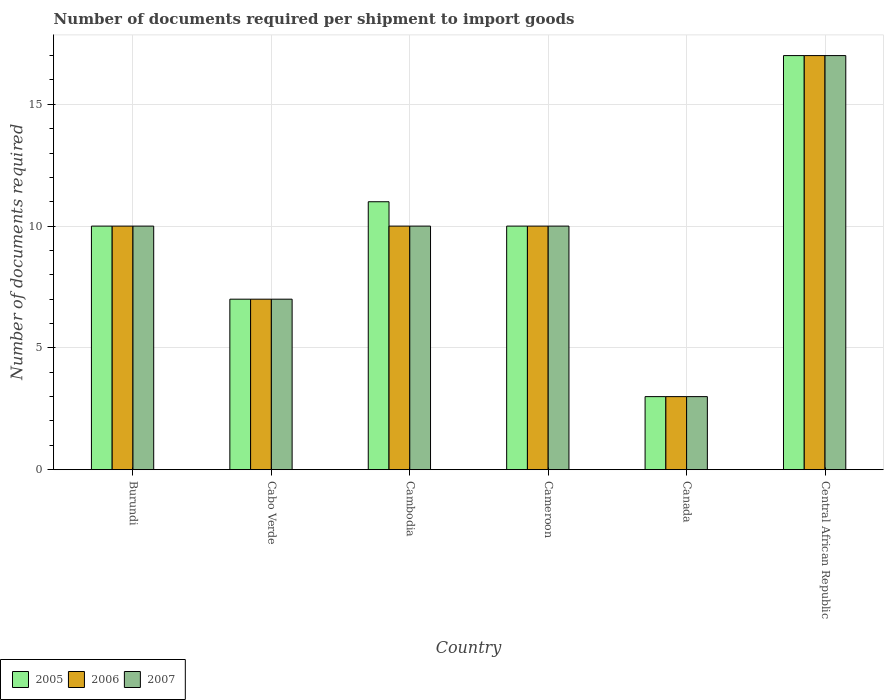Are the number of bars per tick equal to the number of legend labels?
Your answer should be compact. Yes. Are the number of bars on each tick of the X-axis equal?
Provide a succinct answer. Yes. What is the label of the 1st group of bars from the left?
Make the answer very short. Burundi. Across all countries, what is the maximum number of documents required per shipment to import goods in 2005?
Your answer should be very brief. 17. Across all countries, what is the minimum number of documents required per shipment to import goods in 2005?
Your answer should be compact. 3. In which country was the number of documents required per shipment to import goods in 2005 maximum?
Provide a succinct answer. Central African Republic. In which country was the number of documents required per shipment to import goods in 2005 minimum?
Give a very brief answer. Canada. What is the difference between the number of documents required per shipment to import goods in 2006 in Cambodia and the number of documents required per shipment to import goods in 2007 in Burundi?
Provide a succinct answer. 0. What is the average number of documents required per shipment to import goods in 2007 per country?
Give a very brief answer. 9.5. What is the ratio of the number of documents required per shipment to import goods in 2005 in Cabo Verde to that in Canada?
Offer a terse response. 2.33. Is the number of documents required per shipment to import goods in 2005 in Cambodia less than that in Cameroon?
Provide a succinct answer. No. What is the difference between the highest and the second highest number of documents required per shipment to import goods in 2007?
Ensure brevity in your answer.  7. What is the difference between the highest and the lowest number of documents required per shipment to import goods in 2007?
Your answer should be compact. 14. Is the sum of the number of documents required per shipment to import goods in 2007 in Canada and Central African Republic greater than the maximum number of documents required per shipment to import goods in 2006 across all countries?
Make the answer very short. Yes. What does the 1st bar from the left in Cabo Verde represents?
Your answer should be compact. 2005. Is it the case that in every country, the sum of the number of documents required per shipment to import goods in 2005 and number of documents required per shipment to import goods in 2007 is greater than the number of documents required per shipment to import goods in 2006?
Your answer should be compact. Yes. Are all the bars in the graph horizontal?
Make the answer very short. No. How many legend labels are there?
Your answer should be compact. 3. How are the legend labels stacked?
Your answer should be compact. Horizontal. What is the title of the graph?
Provide a short and direct response. Number of documents required per shipment to import goods. Does "1973" appear as one of the legend labels in the graph?
Offer a terse response. No. What is the label or title of the Y-axis?
Your response must be concise. Number of documents required. What is the Number of documents required of 2005 in Burundi?
Ensure brevity in your answer.  10. What is the Number of documents required of 2006 in Cabo Verde?
Offer a terse response. 7. What is the Number of documents required in 2007 in Cabo Verde?
Offer a terse response. 7. What is the Number of documents required in 2005 in Cambodia?
Offer a terse response. 11. What is the Number of documents required in 2006 in Cambodia?
Give a very brief answer. 10. What is the Number of documents required in 2005 in Cameroon?
Your response must be concise. 10. What is the Number of documents required of 2006 in Cameroon?
Offer a terse response. 10. What is the Number of documents required of 2005 in Canada?
Ensure brevity in your answer.  3. What is the Number of documents required of 2007 in Canada?
Give a very brief answer. 3. What is the Number of documents required in 2005 in Central African Republic?
Make the answer very short. 17. What is the Number of documents required in 2006 in Central African Republic?
Your answer should be very brief. 17. Across all countries, what is the maximum Number of documents required in 2007?
Ensure brevity in your answer.  17. Across all countries, what is the minimum Number of documents required in 2006?
Make the answer very short. 3. Across all countries, what is the minimum Number of documents required of 2007?
Provide a succinct answer. 3. What is the total Number of documents required of 2005 in the graph?
Your response must be concise. 58. What is the total Number of documents required of 2007 in the graph?
Your answer should be very brief. 57. What is the difference between the Number of documents required of 2006 in Burundi and that in Cabo Verde?
Offer a very short reply. 3. What is the difference between the Number of documents required of 2005 in Burundi and that in Cambodia?
Keep it short and to the point. -1. What is the difference between the Number of documents required of 2007 in Burundi and that in Cambodia?
Your answer should be very brief. 0. What is the difference between the Number of documents required of 2005 in Burundi and that in Cameroon?
Give a very brief answer. 0. What is the difference between the Number of documents required in 2006 in Burundi and that in Cameroon?
Offer a very short reply. 0. What is the difference between the Number of documents required in 2005 in Burundi and that in Central African Republic?
Make the answer very short. -7. What is the difference between the Number of documents required of 2005 in Cabo Verde and that in Cambodia?
Your answer should be very brief. -4. What is the difference between the Number of documents required in 2006 in Cabo Verde and that in Cambodia?
Provide a short and direct response. -3. What is the difference between the Number of documents required in 2006 in Cabo Verde and that in Cameroon?
Your answer should be very brief. -3. What is the difference between the Number of documents required in 2005 in Cabo Verde and that in Canada?
Make the answer very short. 4. What is the difference between the Number of documents required of 2006 in Cabo Verde and that in Canada?
Your answer should be compact. 4. What is the difference between the Number of documents required of 2007 in Cambodia and that in Cameroon?
Your answer should be very brief. 0. What is the difference between the Number of documents required in 2005 in Cameroon and that in Central African Republic?
Your answer should be very brief. -7. What is the difference between the Number of documents required in 2006 in Cameroon and that in Central African Republic?
Your answer should be very brief. -7. What is the difference between the Number of documents required in 2007 in Cameroon and that in Central African Republic?
Offer a very short reply. -7. What is the difference between the Number of documents required of 2005 in Canada and that in Central African Republic?
Provide a succinct answer. -14. What is the difference between the Number of documents required of 2006 in Canada and that in Central African Republic?
Your response must be concise. -14. What is the difference between the Number of documents required of 2006 in Burundi and the Number of documents required of 2007 in Cabo Verde?
Offer a very short reply. 3. What is the difference between the Number of documents required of 2005 in Burundi and the Number of documents required of 2006 in Cambodia?
Keep it short and to the point. 0. What is the difference between the Number of documents required in 2005 in Burundi and the Number of documents required in 2007 in Cambodia?
Provide a short and direct response. 0. What is the difference between the Number of documents required in 2005 in Burundi and the Number of documents required in 2007 in Canada?
Your answer should be very brief. 7. What is the difference between the Number of documents required of 2005 in Burundi and the Number of documents required of 2006 in Central African Republic?
Your answer should be very brief. -7. What is the difference between the Number of documents required in 2005 in Burundi and the Number of documents required in 2007 in Central African Republic?
Offer a terse response. -7. What is the difference between the Number of documents required in 2005 in Cabo Verde and the Number of documents required in 2006 in Cambodia?
Ensure brevity in your answer.  -3. What is the difference between the Number of documents required in 2006 in Cabo Verde and the Number of documents required in 2007 in Canada?
Offer a terse response. 4. What is the difference between the Number of documents required of 2005 in Cambodia and the Number of documents required of 2006 in Cameroon?
Your answer should be compact. 1. What is the difference between the Number of documents required of 2005 in Cambodia and the Number of documents required of 2007 in Cameroon?
Your response must be concise. 1. What is the difference between the Number of documents required of 2005 in Cambodia and the Number of documents required of 2006 in Canada?
Make the answer very short. 8. What is the difference between the Number of documents required in 2005 in Cambodia and the Number of documents required in 2006 in Central African Republic?
Your answer should be very brief. -6. What is the difference between the Number of documents required in 2005 in Cambodia and the Number of documents required in 2007 in Central African Republic?
Make the answer very short. -6. What is the difference between the Number of documents required of 2006 in Cambodia and the Number of documents required of 2007 in Central African Republic?
Your answer should be very brief. -7. What is the difference between the Number of documents required of 2005 in Cameroon and the Number of documents required of 2007 in Canada?
Give a very brief answer. 7. What is the difference between the Number of documents required in 2006 in Cameroon and the Number of documents required in 2007 in Central African Republic?
Provide a short and direct response. -7. What is the difference between the Number of documents required in 2006 in Canada and the Number of documents required in 2007 in Central African Republic?
Keep it short and to the point. -14. What is the average Number of documents required of 2005 per country?
Make the answer very short. 9.67. What is the average Number of documents required of 2007 per country?
Make the answer very short. 9.5. What is the difference between the Number of documents required of 2005 and Number of documents required of 2007 in Burundi?
Provide a short and direct response. 0. What is the difference between the Number of documents required of 2005 and Number of documents required of 2006 in Cabo Verde?
Ensure brevity in your answer.  0. What is the difference between the Number of documents required of 2005 and Number of documents required of 2006 in Cambodia?
Your response must be concise. 1. What is the difference between the Number of documents required in 2005 and Number of documents required in 2006 in Cameroon?
Keep it short and to the point. 0. What is the difference between the Number of documents required of 2006 and Number of documents required of 2007 in Canada?
Give a very brief answer. 0. What is the difference between the Number of documents required in 2005 and Number of documents required in 2006 in Central African Republic?
Offer a terse response. 0. What is the difference between the Number of documents required of 2005 and Number of documents required of 2007 in Central African Republic?
Offer a terse response. 0. What is the difference between the Number of documents required of 2006 and Number of documents required of 2007 in Central African Republic?
Give a very brief answer. 0. What is the ratio of the Number of documents required of 2005 in Burundi to that in Cabo Verde?
Make the answer very short. 1.43. What is the ratio of the Number of documents required of 2006 in Burundi to that in Cabo Verde?
Your answer should be compact. 1.43. What is the ratio of the Number of documents required in 2007 in Burundi to that in Cabo Verde?
Provide a succinct answer. 1.43. What is the ratio of the Number of documents required in 2007 in Burundi to that in Cameroon?
Give a very brief answer. 1. What is the ratio of the Number of documents required in 2005 in Burundi to that in Canada?
Give a very brief answer. 3.33. What is the ratio of the Number of documents required of 2006 in Burundi to that in Canada?
Your response must be concise. 3.33. What is the ratio of the Number of documents required of 2007 in Burundi to that in Canada?
Offer a terse response. 3.33. What is the ratio of the Number of documents required in 2005 in Burundi to that in Central African Republic?
Offer a very short reply. 0.59. What is the ratio of the Number of documents required of 2006 in Burundi to that in Central African Republic?
Make the answer very short. 0.59. What is the ratio of the Number of documents required of 2007 in Burundi to that in Central African Republic?
Offer a very short reply. 0.59. What is the ratio of the Number of documents required in 2005 in Cabo Verde to that in Cambodia?
Ensure brevity in your answer.  0.64. What is the ratio of the Number of documents required in 2007 in Cabo Verde to that in Cameroon?
Give a very brief answer. 0.7. What is the ratio of the Number of documents required of 2005 in Cabo Verde to that in Canada?
Keep it short and to the point. 2.33. What is the ratio of the Number of documents required of 2006 in Cabo Verde to that in Canada?
Make the answer very short. 2.33. What is the ratio of the Number of documents required in 2007 in Cabo Verde to that in Canada?
Provide a short and direct response. 2.33. What is the ratio of the Number of documents required in 2005 in Cabo Verde to that in Central African Republic?
Your response must be concise. 0.41. What is the ratio of the Number of documents required of 2006 in Cabo Verde to that in Central African Republic?
Give a very brief answer. 0.41. What is the ratio of the Number of documents required in 2007 in Cabo Verde to that in Central African Republic?
Your response must be concise. 0.41. What is the ratio of the Number of documents required of 2005 in Cambodia to that in Canada?
Provide a succinct answer. 3.67. What is the ratio of the Number of documents required in 2005 in Cambodia to that in Central African Republic?
Provide a short and direct response. 0.65. What is the ratio of the Number of documents required in 2006 in Cambodia to that in Central African Republic?
Provide a short and direct response. 0.59. What is the ratio of the Number of documents required in 2007 in Cambodia to that in Central African Republic?
Provide a succinct answer. 0.59. What is the ratio of the Number of documents required in 2007 in Cameroon to that in Canada?
Give a very brief answer. 3.33. What is the ratio of the Number of documents required of 2005 in Cameroon to that in Central African Republic?
Give a very brief answer. 0.59. What is the ratio of the Number of documents required in 2006 in Cameroon to that in Central African Republic?
Your response must be concise. 0.59. What is the ratio of the Number of documents required in 2007 in Cameroon to that in Central African Republic?
Your answer should be very brief. 0.59. What is the ratio of the Number of documents required of 2005 in Canada to that in Central African Republic?
Keep it short and to the point. 0.18. What is the ratio of the Number of documents required of 2006 in Canada to that in Central African Republic?
Provide a succinct answer. 0.18. What is the ratio of the Number of documents required in 2007 in Canada to that in Central African Republic?
Your answer should be compact. 0.18. What is the difference between the highest and the second highest Number of documents required of 2005?
Make the answer very short. 6. What is the difference between the highest and the second highest Number of documents required in 2006?
Provide a short and direct response. 7. What is the difference between the highest and the lowest Number of documents required in 2006?
Keep it short and to the point. 14. What is the difference between the highest and the lowest Number of documents required in 2007?
Offer a very short reply. 14. 